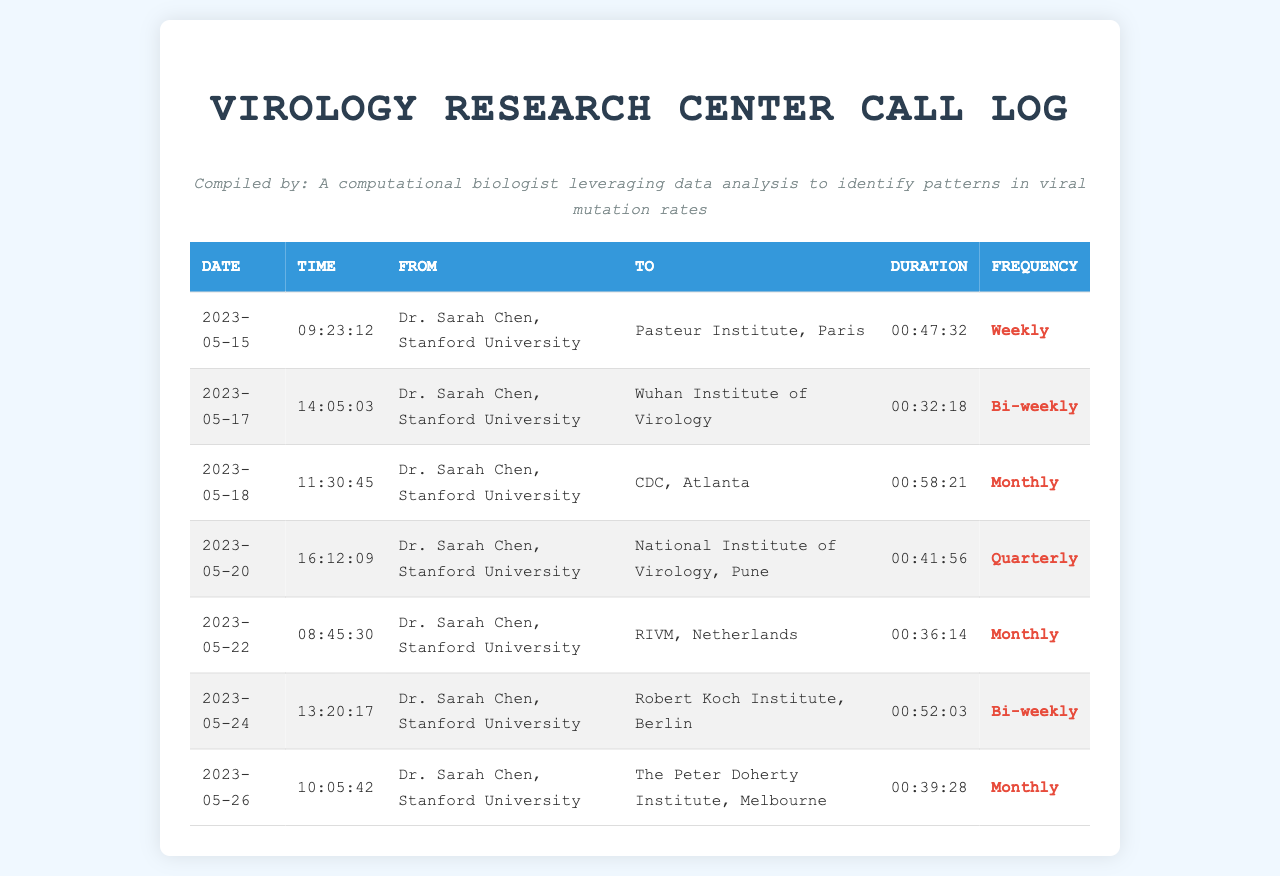What is the duration of the call to the Pasteur Institute? The duration of the call to the Pasteur Institute on May 15 is given as 00:47:32.
Answer: 00:47:32 Who is the caller for all recorded calls? The document shows that Dr. Sarah Chen from Stanford University is the caller for all calls listed in the log.
Answer: Dr. Sarah Chen, Stanford University How often does Dr. Chen call the Robert Koch Institute? The frequency of the call to the Robert Koch Institute is listed as Bi-weekly.
Answer: Bi-weekly What is the total number of calls made to international research centers? The document details a total of 7 calls made to various international research centers.
Answer: 7 Which research center is called the most frequently? The national research centers do not have the same frequency; the most frequent call is made to the Pasteur Institute with a Weekly frequency.
Answer: Pasteur Institute, Paris What was the call duration to the CDC in Atlanta? The call duration to the CDC on May 18 is documented as 00:58:21.
Answer: 00:58:21 When did Dr. Chen last call the National Institute of Virology in Pune? The last recorded call to the National Institute of Virology was made on May 20, 2023.
Answer: 2023-05-20 What is the duration of the shortest call made by Dr. Chen? According to the log, the shortest call duration to the Wuhan Institute of Virology is recorded as 00:32:18.
Answer: 00:32:18 